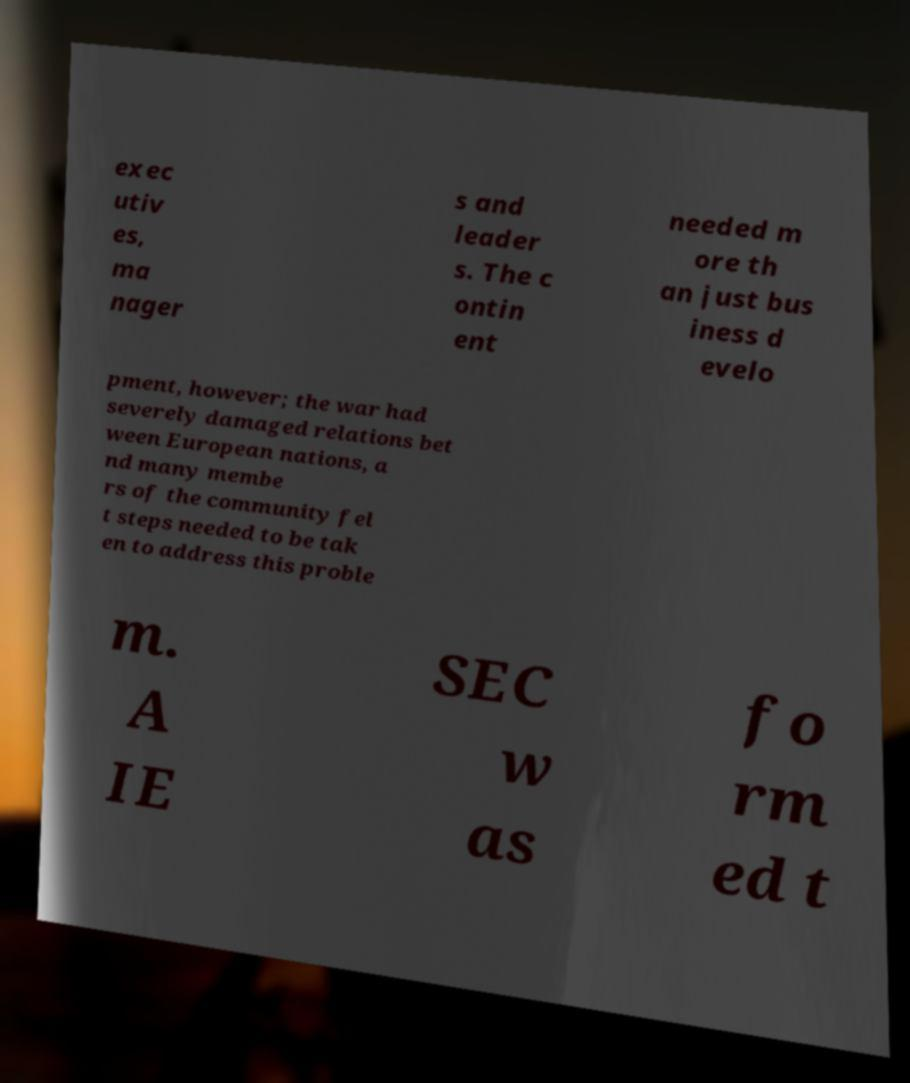There's text embedded in this image that I need extracted. Can you transcribe it verbatim? exec utiv es, ma nager s and leader s. The c ontin ent needed m ore th an just bus iness d evelo pment, however; the war had severely damaged relations bet ween European nations, a nd many membe rs of the community fel t steps needed to be tak en to address this proble m. A IE SEC w as fo rm ed t 